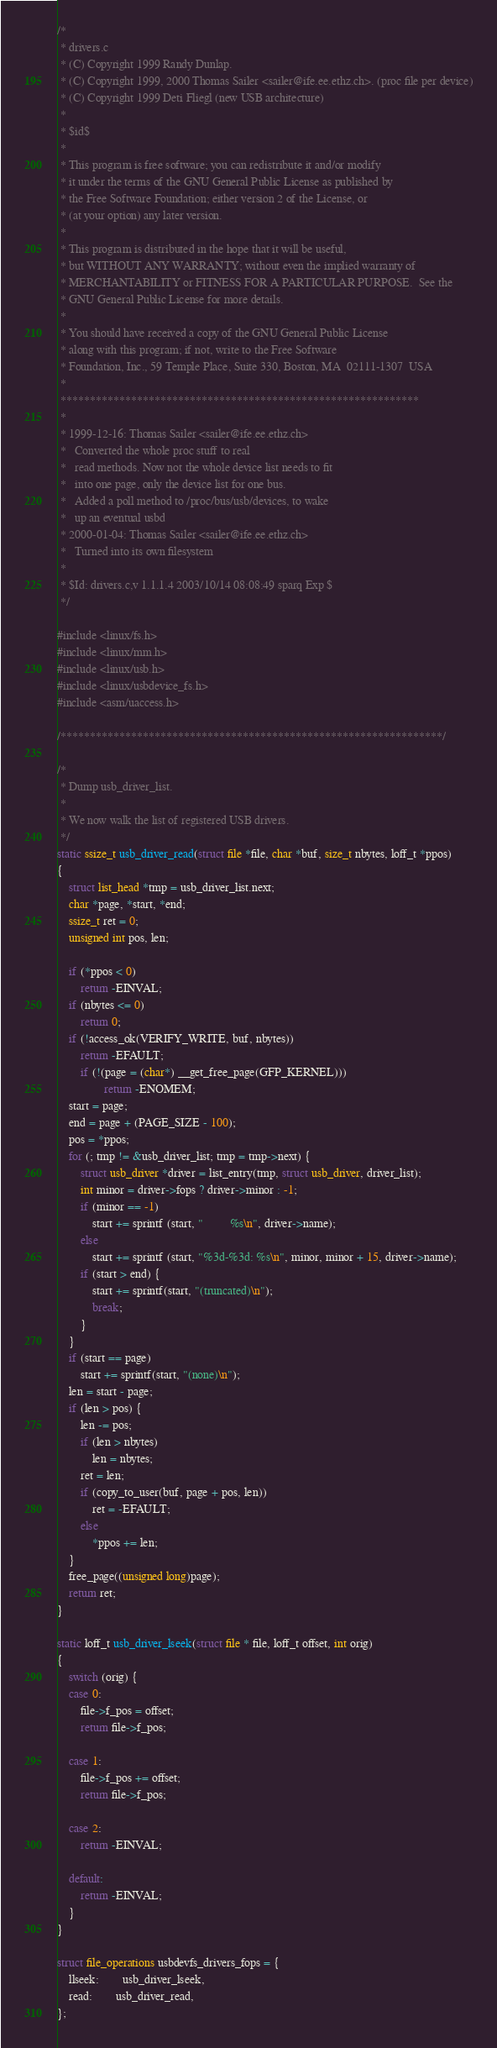<code> <loc_0><loc_0><loc_500><loc_500><_C_>/*
 * drivers.c
 * (C) Copyright 1999 Randy Dunlap.
 * (C) Copyright 1999, 2000 Thomas Sailer <sailer@ife.ee.ethz.ch>. (proc file per device)
 * (C) Copyright 1999 Deti Fliegl (new USB architecture)
 *
 * $id$
 *
 * This program is free software; you can redistribute it and/or modify
 * it under the terms of the GNU General Public License as published by
 * the Free Software Foundation; either version 2 of the License, or
 * (at your option) any later version.
 *
 * This program is distributed in the hope that it will be useful,
 * but WITHOUT ANY WARRANTY; without even the implied warranty of
 * MERCHANTABILITY or FITNESS FOR A PARTICULAR PURPOSE.  See the
 * GNU General Public License for more details.
 *
 * You should have received a copy of the GNU General Public License
 * along with this program; if not, write to the Free Software
 * Foundation, Inc., 59 Temple Place, Suite 330, Boston, MA  02111-1307  USA
 *
 *************************************************************
 *
 * 1999-12-16: Thomas Sailer <sailer@ife.ee.ethz.ch>
 *   Converted the whole proc stuff to real
 *   read methods. Now not the whole device list needs to fit
 *   into one page, only the device list for one bus.
 *   Added a poll method to /proc/bus/usb/devices, to wake
 *   up an eventual usbd
 * 2000-01-04: Thomas Sailer <sailer@ife.ee.ethz.ch>
 *   Turned into its own filesystem
 *
 * $Id: drivers.c,v 1.1.1.4 2003/10/14 08:08:49 sparq Exp $
 */

#include <linux/fs.h>
#include <linux/mm.h>
#include <linux/usb.h>
#include <linux/usbdevice_fs.h>
#include <asm/uaccess.h>

/*****************************************************************/

/*
 * Dump usb_driver_list.
 *
 * We now walk the list of registered USB drivers.
 */
static ssize_t usb_driver_read(struct file *file, char *buf, size_t nbytes, loff_t *ppos)
{
	struct list_head *tmp = usb_driver_list.next;
	char *page, *start, *end;
	ssize_t ret = 0;
	unsigned int pos, len;

	if (*ppos < 0)
		return -EINVAL;
	if (nbytes <= 0)
		return 0;
	if (!access_ok(VERIFY_WRITE, buf, nbytes))
		return -EFAULT;
        if (!(page = (char*) __get_free_page(GFP_KERNEL)))
                return -ENOMEM;
	start = page;
	end = page + (PAGE_SIZE - 100);
	pos = *ppos;
	for (; tmp != &usb_driver_list; tmp = tmp->next) {
		struct usb_driver *driver = list_entry(tmp, struct usb_driver, driver_list);
		int minor = driver->fops ? driver->minor : -1;
		if (minor == -1)
			start += sprintf (start, "         %s\n", driver->name);
		else
			start += sprintf (start, "%3d-%3d: %s\n", minor, minor + 15, driver->name);
		if (start > end) {
			start += sprintf(start, "(truncated)\n");
			break;
		}
	}
	if (start == page)
		start += sprintf(start, "(none)\n");
	len = start - page;
	if (len > pos) {
		len -= pos;
		if (len > nbytes)
			len = nbytes;
		ret = len;
		if (copy_to_user(buf, page + pos, len))
			ret = -EFAULT;
		else
			*ppos += len;
	}
	free_page((unsigned long)page);
	return ret;
}

static loff_t usb_driver_lseek(struct file * file, loff_t offset, int orig)
{
	switch (orig) {
	case 0:
		file->f_pos = offset;
		return file->f_pos;

	case 1:
		file->f_pos += offset;
		return file->f_pos;

	case 2:
		return -EINVAL;

	default:
		return -EINVAL;
	}
}

struct file_operations usbdevfs_drivers_fops = {
	llseek:		usb_driver_lseek,
	read:		usb_driver_read,
};
</code> 